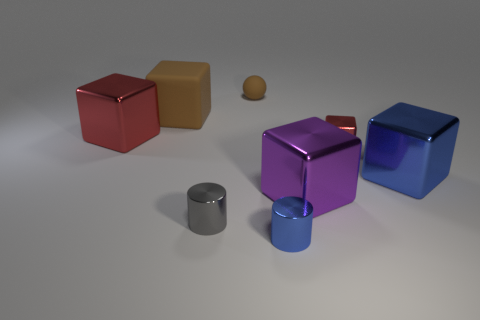Subtract all blue cubes. How many cubes are left? 4 Subtract all gray blocks. Subtract all gray spheres. How many blocks are left? 5 Add 1 tiny gray shiny cylinders. How many objects exist? 9 Subtract all balls. How many objects are left? 7 Add 6 gray metal objects. How many gray metal objects exist? 7 Subtract 1 brown spheres. How many objects are left? 7 Subtract all purple metal objects. Subtract all purple things. How many objects are left? 6 Add 8 gray shiny things. How many gray shiny things are left? 9 